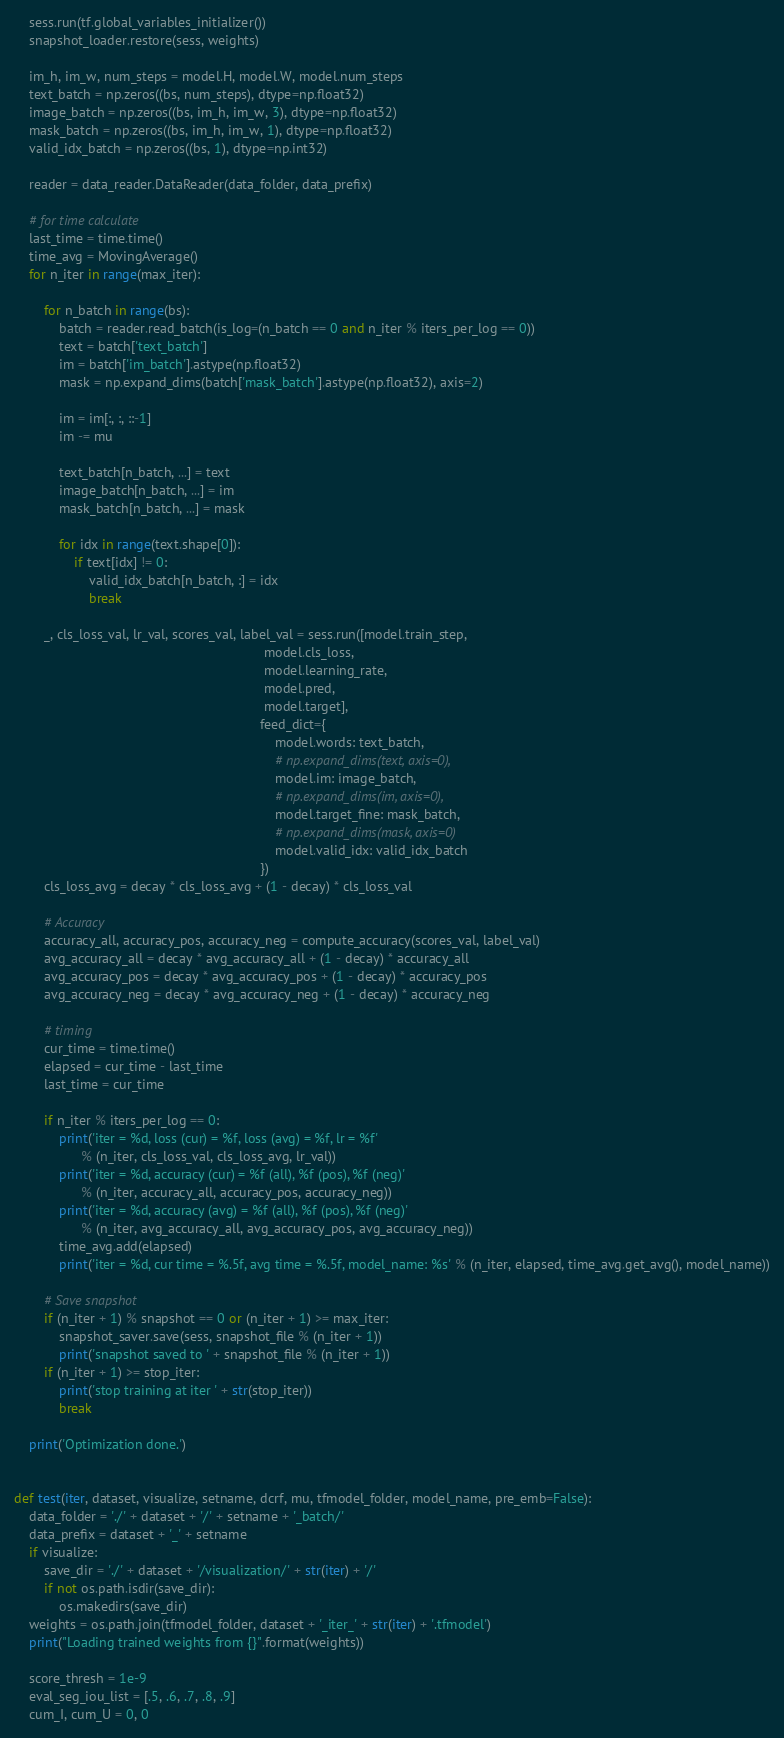Convert code to text. <code><loc_0><loc_0><loc_500><loc_500><_Python_>    sess.run(tf.global_variables_initializer())
    snapshot_loader.restore(sess, weights)

    im_h, im_w, num_steps = model.H, model.W, model.num_steps
    text_batch = np.zeros((bs, num_steps), dtype=np.float32)
    image_batch = np.zeros((bs, im_h, im_w, 3), dtype=np.float32)
    mask_batch = np.zeros((bs, im_h, im_w, 1), dtype=np.float32)
    valid_idx_batch = np.zeros((bs, 1), dtype=np.int32)

    reader = data_reader.DataReader(data_folder, data_prefix)

    # for time calculate
    last_time = time.time()
    time_avg = MovingAverage()
    for n_iter in range(max_iter):

        for n_batch in range(bs):
            batch = reader.read_batch(is_log=(n_batch == 0 and n_iter % iters_per_log == 0))
            text = batch['text_batch']
            im = batch['im_batch'].astype(np.float32)
            mask = np.expand_dims(batch['mask_batch'].astype(np.float32), axis=2)

            im = im[:, :, ::-1]
            im -= mu

            text_batch[n_batch, ...] = text
            image_batch[n_batch, ...] = im
            mask_batch[n_batch, ...] = mask

            for idx in range(text.shape[0]):
                if text[idx] != 0:
                    valid_idx_batch[n_batch, :] = idx
                    break

        _, cls_loss_val, lr_val, scores_val, label_val = sess.run([model.train_step,
                                                                   model.cls_loss,
                                                                   model.learning_rate,
                                                                   model.pred,
                                                                   model.target],
                                                                  feed_dict={
                                                                      model.words: text_batch,
                                                                      # np.expand_dims(text, axis=0),
                                                                      model.im: image_batch,
                                                                      # np.expand_dims(im, axis=0),
                                                                      model.target_fine: mask_batch,
                                                                      # np.expand_dims(mask, axis=0)
                                                                      model.valid_idx: valid_idx_batch
                                                                  })
        cls_loss_avg = decay * cls_loss_avg + (1 - decay) * cls_loss_val

        # Accuracy
        accuracy_all, accuracy_pos, accuracy_neg = compute_accuracy(scores_val, label_val)
        avg_accuracy_all = decay * avg_accuracy_all + (1 - decay) * accuracy_all
        avg_accuracy_pos = decay * avg_accuracy_pos + (1 - decay) * accuracy_pos
        avg_accuracy_neg = decay * avg_accuracy_neg + (1 - decay) * accuracy_neg

        # timing
        cur_time = time.time()
        elapsed = cur_time - last_time
        last_time = cur_time

        if n_iter % iters_per_log == 0:
            print('iter = %d, loss (cur) = %f, loss (avg) = %f, lr = %f'
                  % (n_iter, cls_loss_val, cls_loss_avg, lr_val))
            print('iter = %d, accuracy (cur) = %f (all), %f (pos), %f (neg)'
                  % (n_iter, accuracy_all, accuracy_pos, accuracy_neg))
            print('iter = %d, accuracy (avg) = %f (all), %f (pos), %f (neg)'
                  % (n_iter, avg_accuracy_all, avg_accuracy_pos, avg_accuracy_neg))
            time_avg.add(elapsed)
            print('iter = %d, cur time = %.5f, avg time = %.5f, model_name: %s' % (n_iter, elapsed, time_avg.get_avg(), model_name))

        # Save snapshot
        if (n_iter + 1) % snapshot == 0 or (n_iter + 1) >= max_iter:
            snapshot_saver.save(sess, snapshot_file % (n_iter + 1))
            print('snapshot saved to ' + snapshot_file % (n_iter + 1))
        if (n_iter + 1) >= stop_iter:
            print('stop training at iter ' + str(stop_iter))
            break

    print('Optimization done.')


def test(iter, dataset, visualize, setname, dcrf, mu, tfmodel_folder, model_name, pre_emb=False):
    data_folder = './' + dataset + '/' + setname + '_batch/'
    data_prefix = dataset + '_' + setname
    if visualize:
        save_dir = './' + dataset + '/visualization/' + str(iter) + '/'
        if not os.path.isdir(save_dir):
            os.makedirs(save_dir)
    weights = os.path.join(tfmodel_folder, dataset + '_iter_' + str(iter) + '.tfmodel')
    print("Loading trained weights from {}".format(weights))

    score_thresh = 1e-9
    eval_seg_iou_list = [.5, .6, .7, .8, .9]
    cum_I, cum_U = 0, 0</code> 